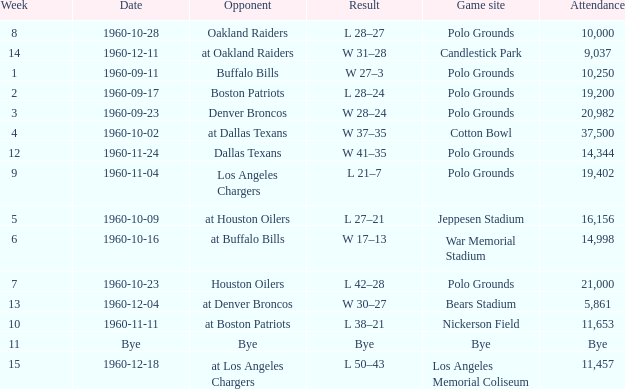What day did they play at candlestick park? 1960-12-11. Would you mind parsing the complete table? {'header': ['Week', 'Date', 'Opponent', 'Result', 'Game site', 'Attendance'], 'rows': [['8', '1960-10-28', 'Oakland Raiders', 'L 28–27', 'Polo Grounds', '10,000'], ['14', '1960-12-11', 'at Oakland Raiders', 'W 31–28', 'Candlestick Park', '9,037'], ['1', '1960-09-11', 'Buffalo Bills', 'W 27–3', 'Polo Grounds', '10,250'], ['2', '1960-09-17', 'Boston Patriots', 'L 28–24', 'Polo Grounds', '19,200'], ['3', '1960-09-23', 'Denver Broncos', 'W 28–24', 'Polo Grounds', '20,982'], ['4', '1960-10-02', 'at Dallas Texans', 'W 37–35', 'Cotton Bowl', '37,500'], ['12', '1960-11-24', 'Dallas Texans', 'W 41–35', 'Polo Grounds', '14,344'], ['9', '1960-11-04', 'Los Angeles Chargers', 'L 21–7', 'Polo Grounds', '19,402'], ['5', '1960-10-09', 'at Houston Oilers', 'L 27–21', 'Jeppesen Stadium', '16,156'], ['6', '1960-10-16', 'at Buffalo Bills', 'W 17–13', 'War Memorial Stadium', '14,998'], ['7', '1960-10-23', 'Houston Oilers', 'L 42–28', 'Polo Grounds', '21,000'], ['13', '1960-12-04', 'at Denver Broncos', 'W 30–27', 'Bears Stadium', '5,861'], ['10', '1960-11-11', 'at Boston Patriots', 'L 38–21', 'Nickerson Field', '11,653'], ['11', 'Bye', 'Bye', 'Bye', 'Bye', 'Bye'], ['15', '1960-12-18', 'at Los Angeles Chargers', 'L 50–43', 'Los Angeles Memorial Coliseum', '11,457']]} 